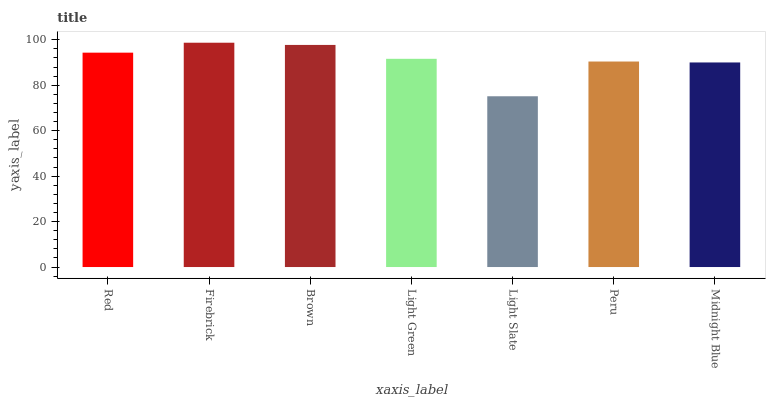Is Light Slate the minimum?
Answer yes or no. Yes. Is Firebrick the maximum?
Answer yes or no. Yes. Is Brown the minimum?
Answer yes or no. No. Is Brown the maximum?
Answer yes or no. No. Is Firebrick greater than Brown?
Answer yes or no. Yes. Is Brown less than Firebrick?
Answer yes or no. Yes. Is Brown greater than Firebrick?
Answer yes or no. No. Is Firebrick less than Brown?
Answer yes or no. No. Is Light Green the high median?
Answer yes or no. Yes. Is Light Green the low median?
Answer yes or no. Yes. Is Red the high median?
Answer yes or no. No. Is Light Slate the low median?
Answer yes or no. No. 